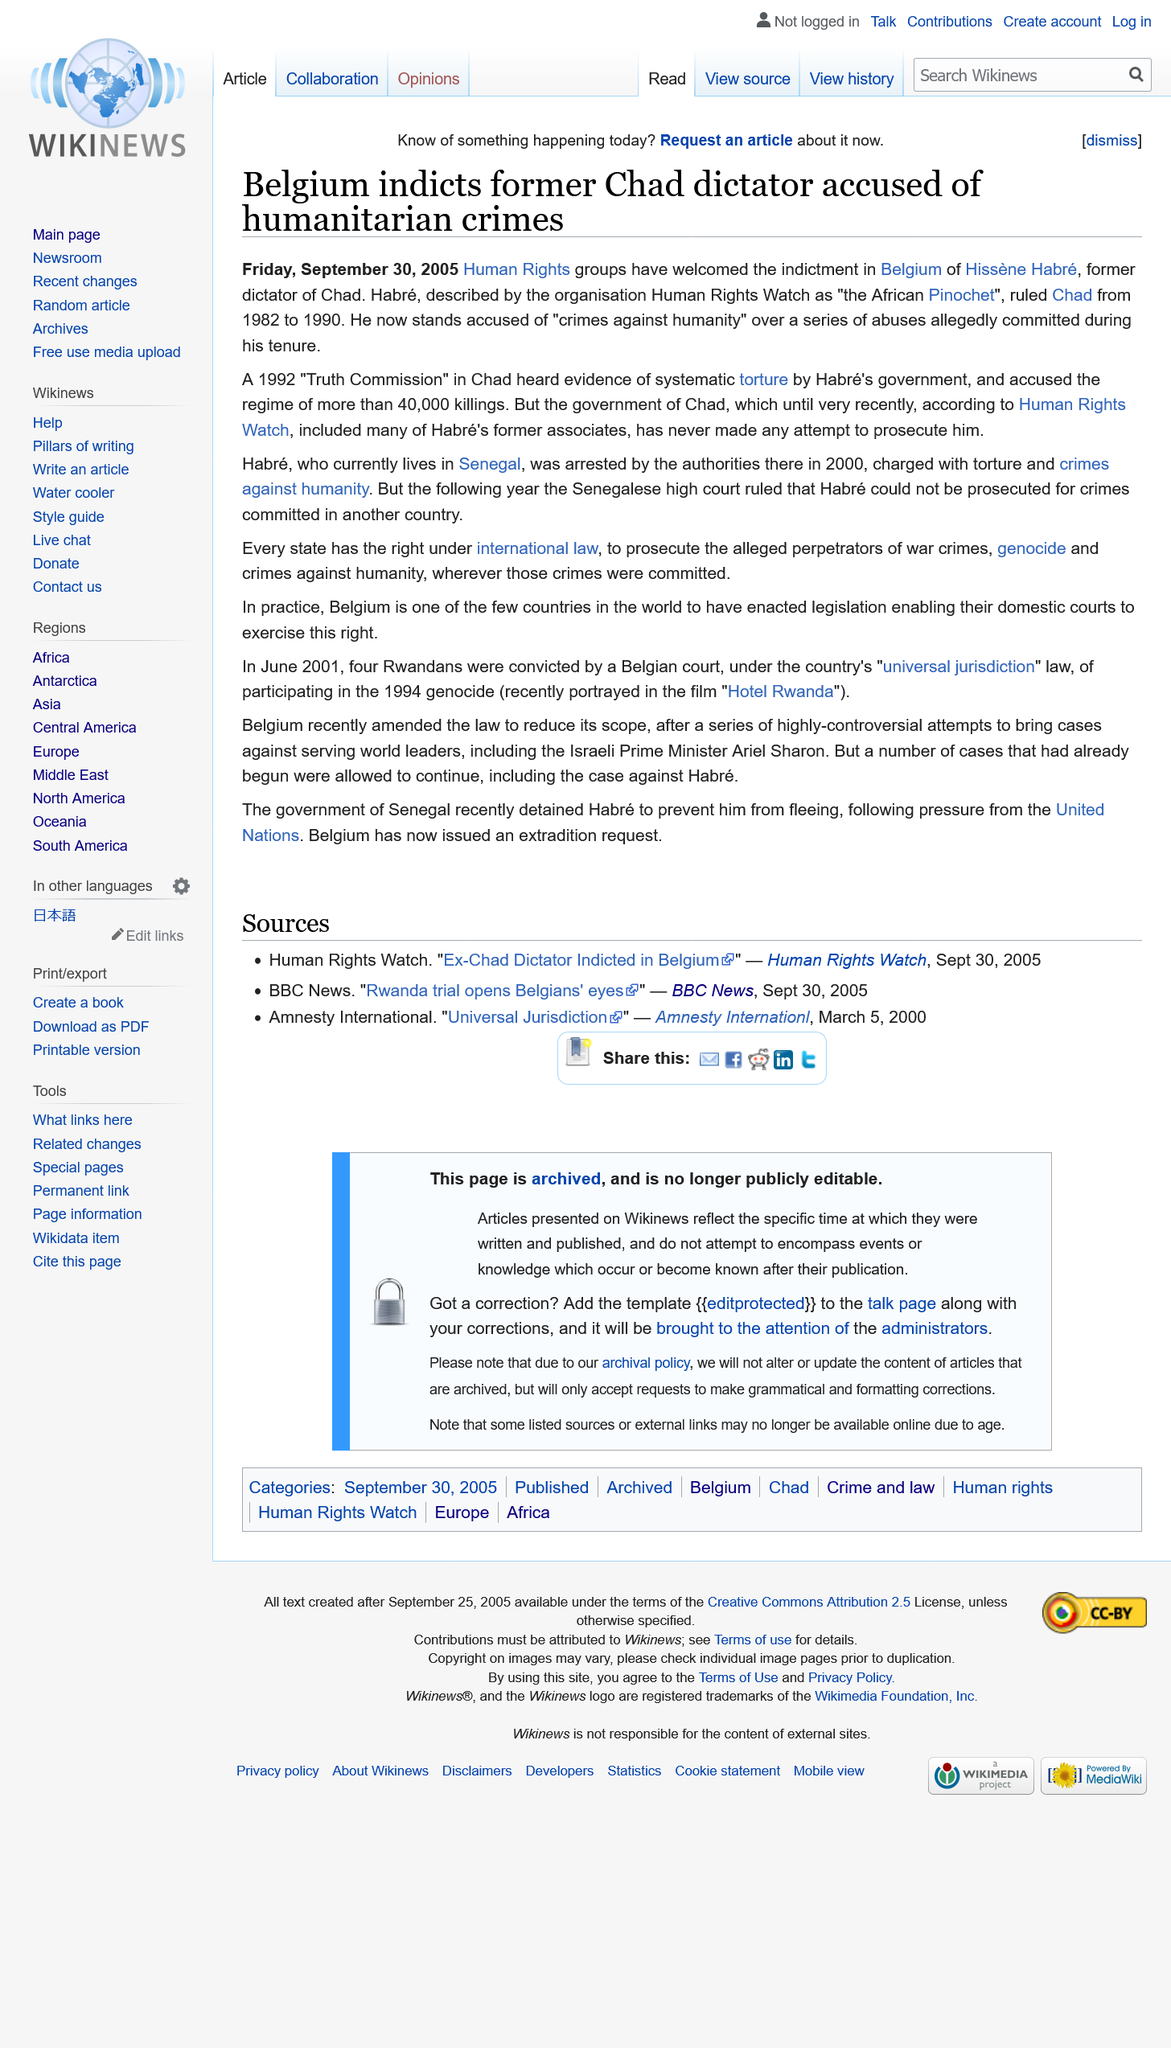Identify some key points in this picture. Hissène Habré was arrested and charged with torture and crimes against humanity. Belgians have accused the former dictator of Chad of committing humanitarian crimes. Hissene Habré, the former dictator of Chad, was the subject of a declaration. 